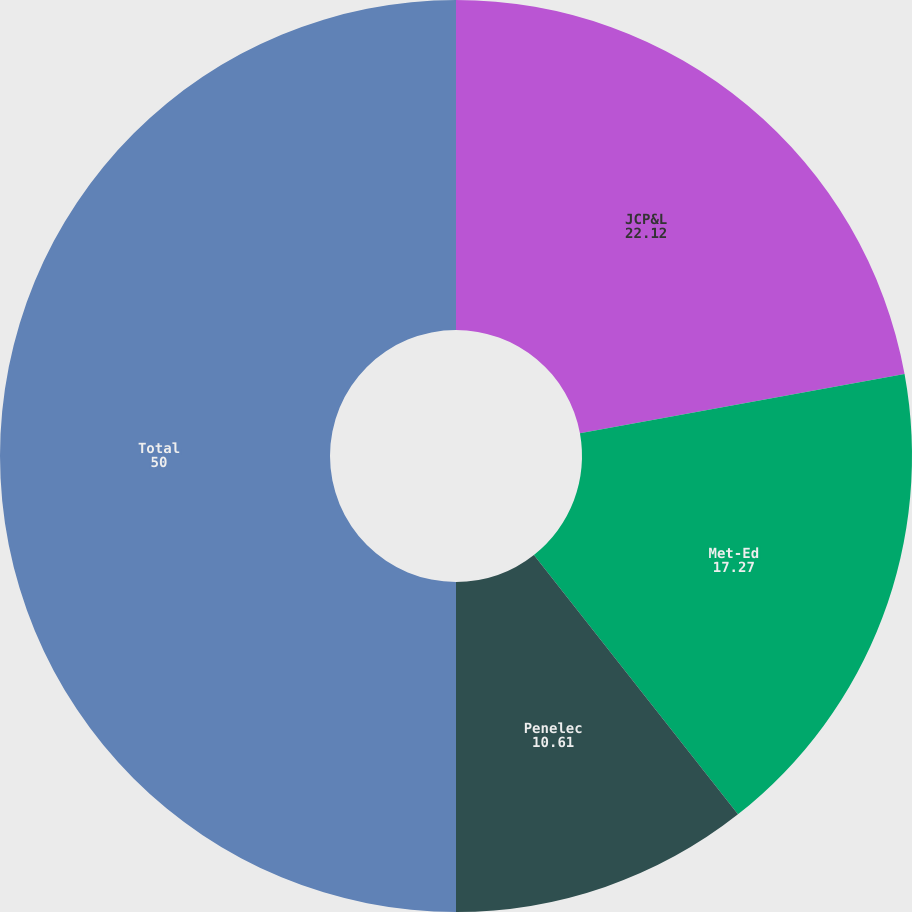Convert chart. <chart><loc_0><loc_0><loc_500><loc_500><pie_chart><fcel>JCP&L<fcel>Met-Ed<fcel>Penelec<fcel>Total<nl><fcel>22.12%<fcel>17.27%<fcel>10.61%<fcel>50.0%<nl></chart> 